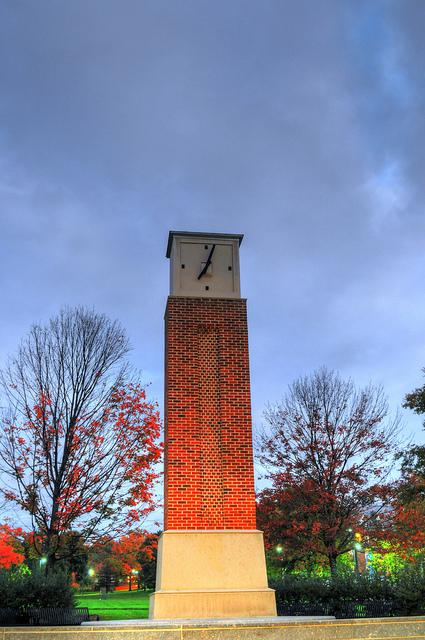What time is it?
Quick response, please. 7:00. What is the season?
Keep it brief. Fall. Where is the clock located?
Concise answer only. Park. 